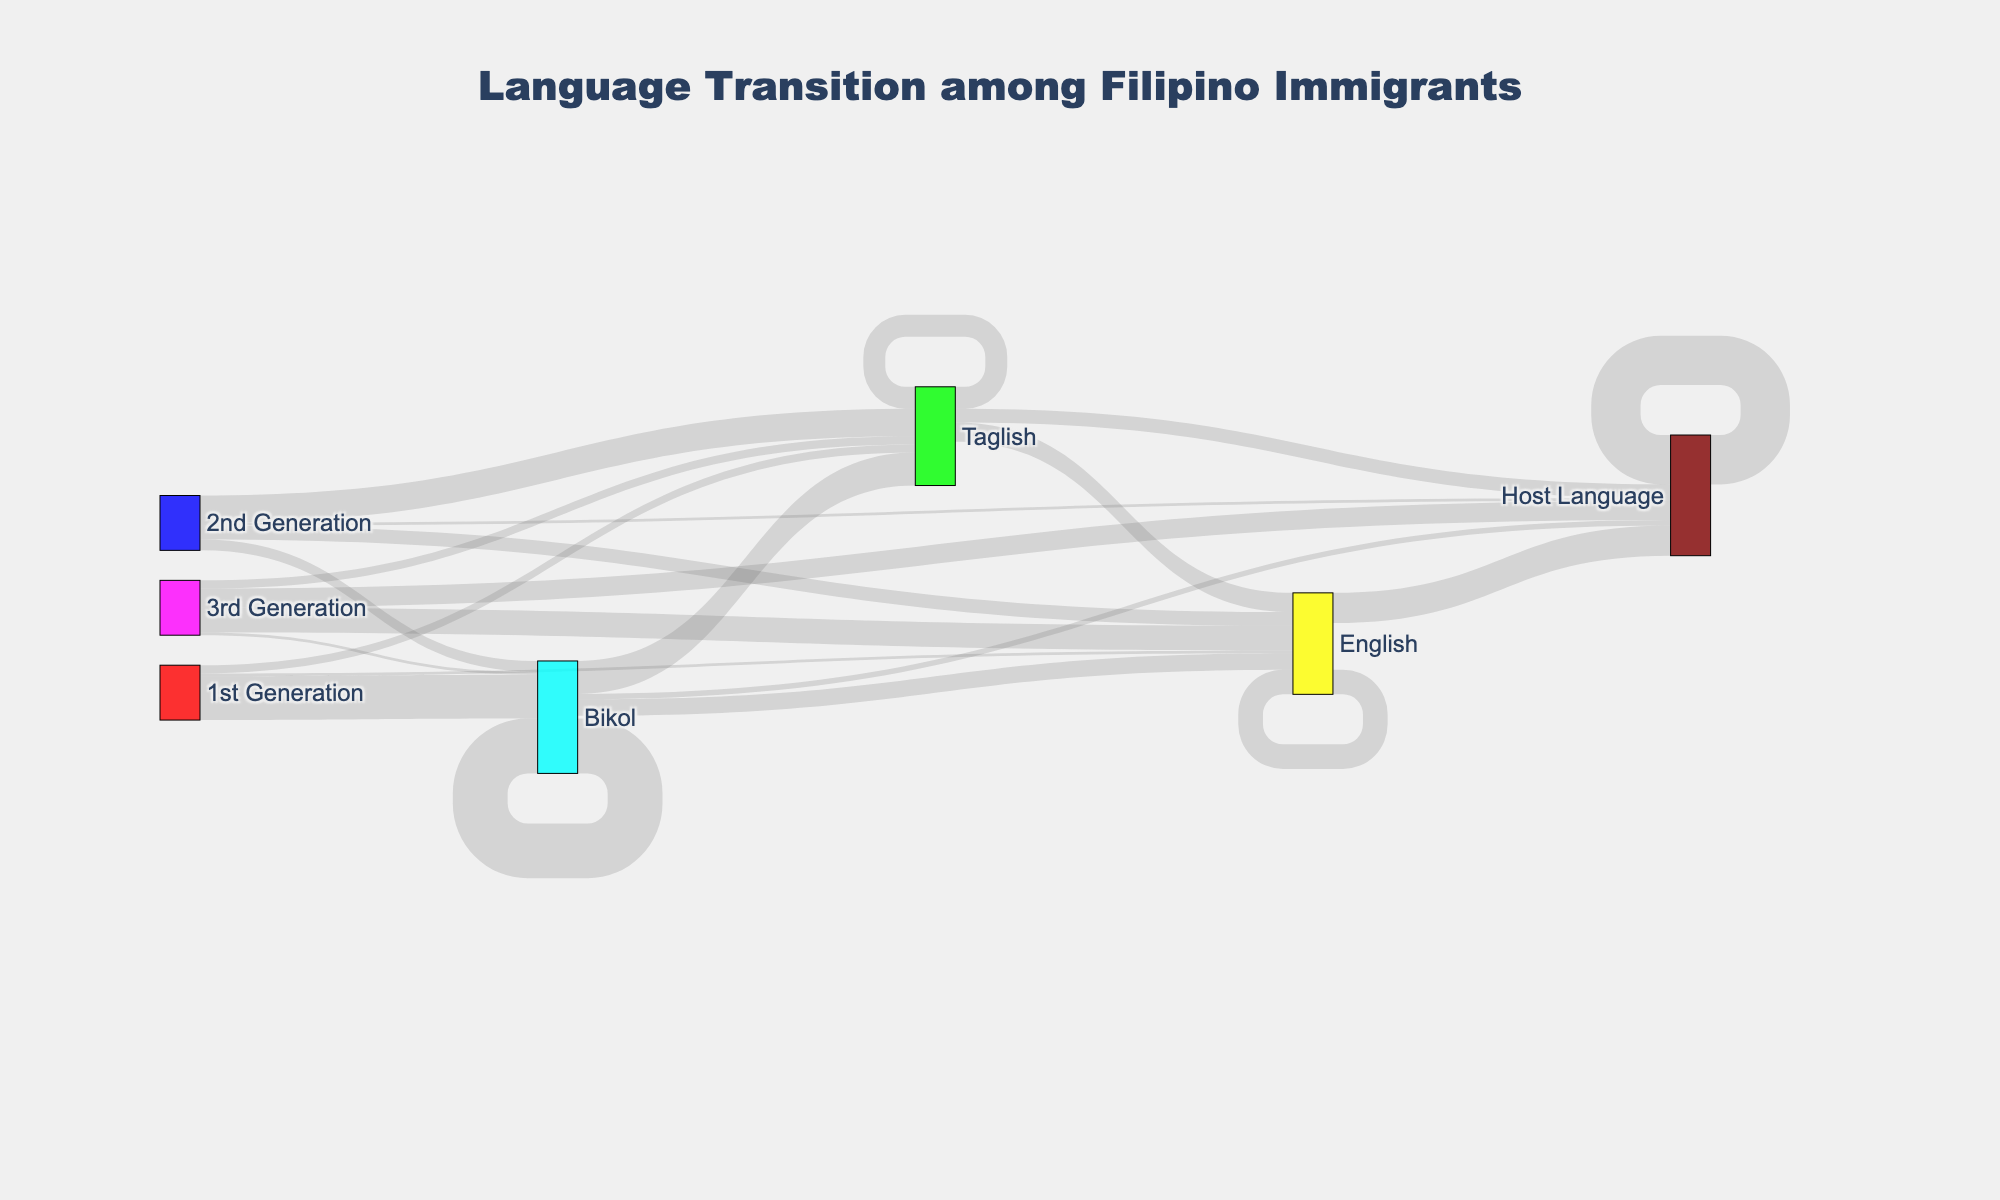What is the main title of the figure? The main title is typically placed at the top of the figure. In this case, it is specified in the code as "Language Transition among Filipino Immigrants".
Answer: Language Transition among Filipino Immigrants Which generation has the largest proportion of people transitioning from Bikol to Taglish? Look at the different links that start with "Bikol" and end with "Taglish" for each generation. The proportion is reflected by the link value. The largest link value for this transition occurs in the 2nd Generation.
Answer: 2nd Generation How many people from the 3rd Generation speak Taglish? Locate the node with "3rd Generation" and follow the connected link that ends in "Taglish". The link value is given as 15.
Answer: 15 What is the total number of people in the 1st Generation who transition away from Taglish? From the 1st Generation "Taglish" node, sum the values of transitions to other nodes: only two transitions (15 to Taglish itself and 25 to Host Language). This contributes 40 + 25 = 65.
Answer: 40 Which language retains the highest number of native speakers across generations? Observe the outgoing links from languages back to themselves. "Host Language" retains the highest number of native speakers as evidenced by the link value of 90.
Answer: Host Language How does the number of 3rd Generation individuals who use English compare to those using the Host Language? Check the 3rd Generation links leading to "English" and "Host Language". The values are 45 and 35, respectively, meaning more individuals use English.
Answer: More use English What are the proportions of 1st Generation individuals who speak Bikol, Taglish, and English initially? Look at the outgoing links from "1st Generation" to "Bikol", "Taglish", and "English". The values are 80, 15, and 5 respectively. The total is 80 + 15 + 5 = 100. So, proportions are: Bikol - 80%, Taglish - 15%, English - 5%.
Answer: Bikol - 80%, Taglish - 15%, English - 5% Which language shows the highest growth in use from 1st to 3rd Generation? Compare the link values transitioning into each language from "1st Generation" to "3rd Generation". "Host Language" shows the most significant growth with values increasing from 5 in the 1st to 35 in the 3rd Generation.
Answer: Host Language What is the total number of people across all generations speaking the Host Language? Sum all the values for links that end with "Host Language". These values are 10 (Bikol to Host Language) + 25 (Taglish to Host Language) + 55 (English to Host Language) + 90 (Host Language to Host Language).
Answer: 180 How does the transition from Bikol to Host Language change across generations? Trace the links from "Bikol" to "Host Language" across different generations. For the 1st Generation, the link value is 10. For the 2nd and 3rd Generations, there is no direct transition, indicating the primary transitions occur earlier.
Answer: Decreases 